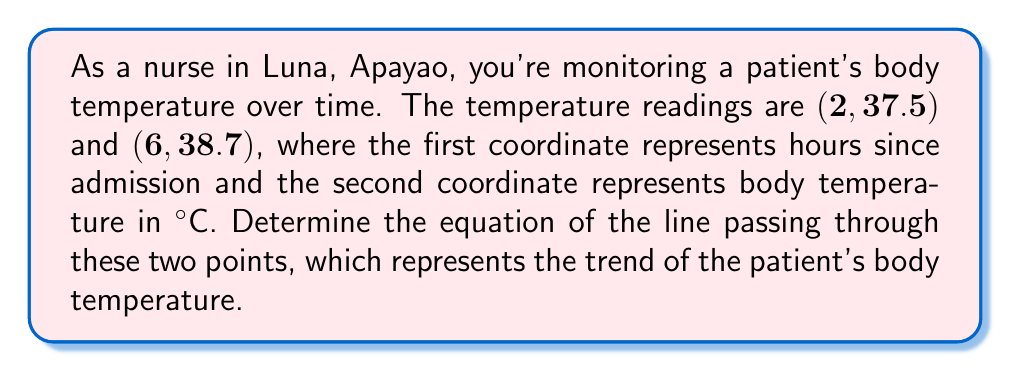Solve this math problem. To find the equation of a line passing through two points, we can use the point-slope form of a line: $y - y_1 = m(x - x_1)$, where $m$ is the slope of the line.

Step 1: Calculate the slope $(m)$ using the two given points.
$m = \frac{y_2 - y_1}{x_2 - x_1} = \frac{38.7 - 37.5}{6 - 2} = \frac{1.2}{4} = 0.3$

Step 2: Choose one of the points to use in the point-slope form. Let's use $(2, 37.5)$.

Step 3: Substitute the slope and the chosen point into the point-slope form.
$y - 37.5 = 0.3(x - 2)$

Step 4: Distribute the 0.3.
$y - 37.5 = 0.3x - 0.6$

Step 5: Add 37.5 to both sides to isolate $y$.
$y = 0.3x - 0.6 + 37.5$

Step 6: Simplify.
$y = 0.3x + 36.9$

This equation represents the trend of the patient's body temperature over time.
Answer: $y = 0.3x + 36.9$ 